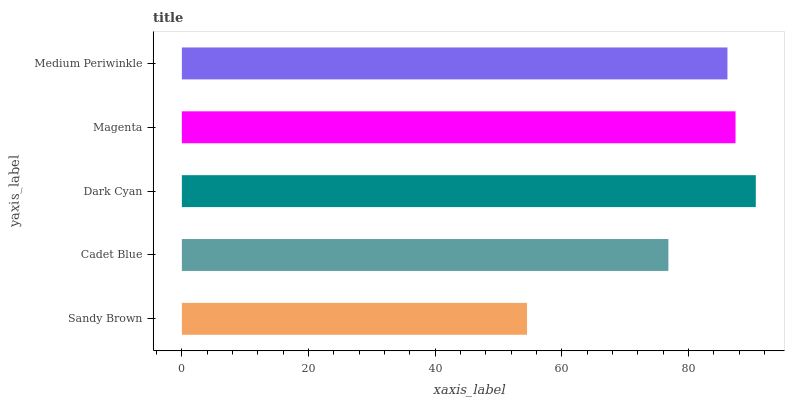Is Sandy Brown the minimum?
Answer yes or no. Yes. Is Dark Cyan the maximum?
Answer yes or no. Yes. Is Cadet Blue the minimum?
Answer yes or no. No. Is Cadet Blue the maximum?
Answer yes or no. No. Is Cadet Blue greater than Sandy Brown?
Answer yes or no. Yes. Is Sandy Brown less than Cadet Blue?
Answer yes or no. Yes. Is Sandy Brown greater than Cadet Blue?
Answer yes or no. No. Is Cadet Blue less than Sandy Brown?
Answer yes or no. No. Is Medium Periwinkle the high median?
Answer yes or no. Yes. Is Medium Periwinkle the low median?
Answer yes or no. Yes. Is Dark Cyan the high median?
Answer yes or no. No. Is Sandy Brown the low median?
Answer yes or no. No. 